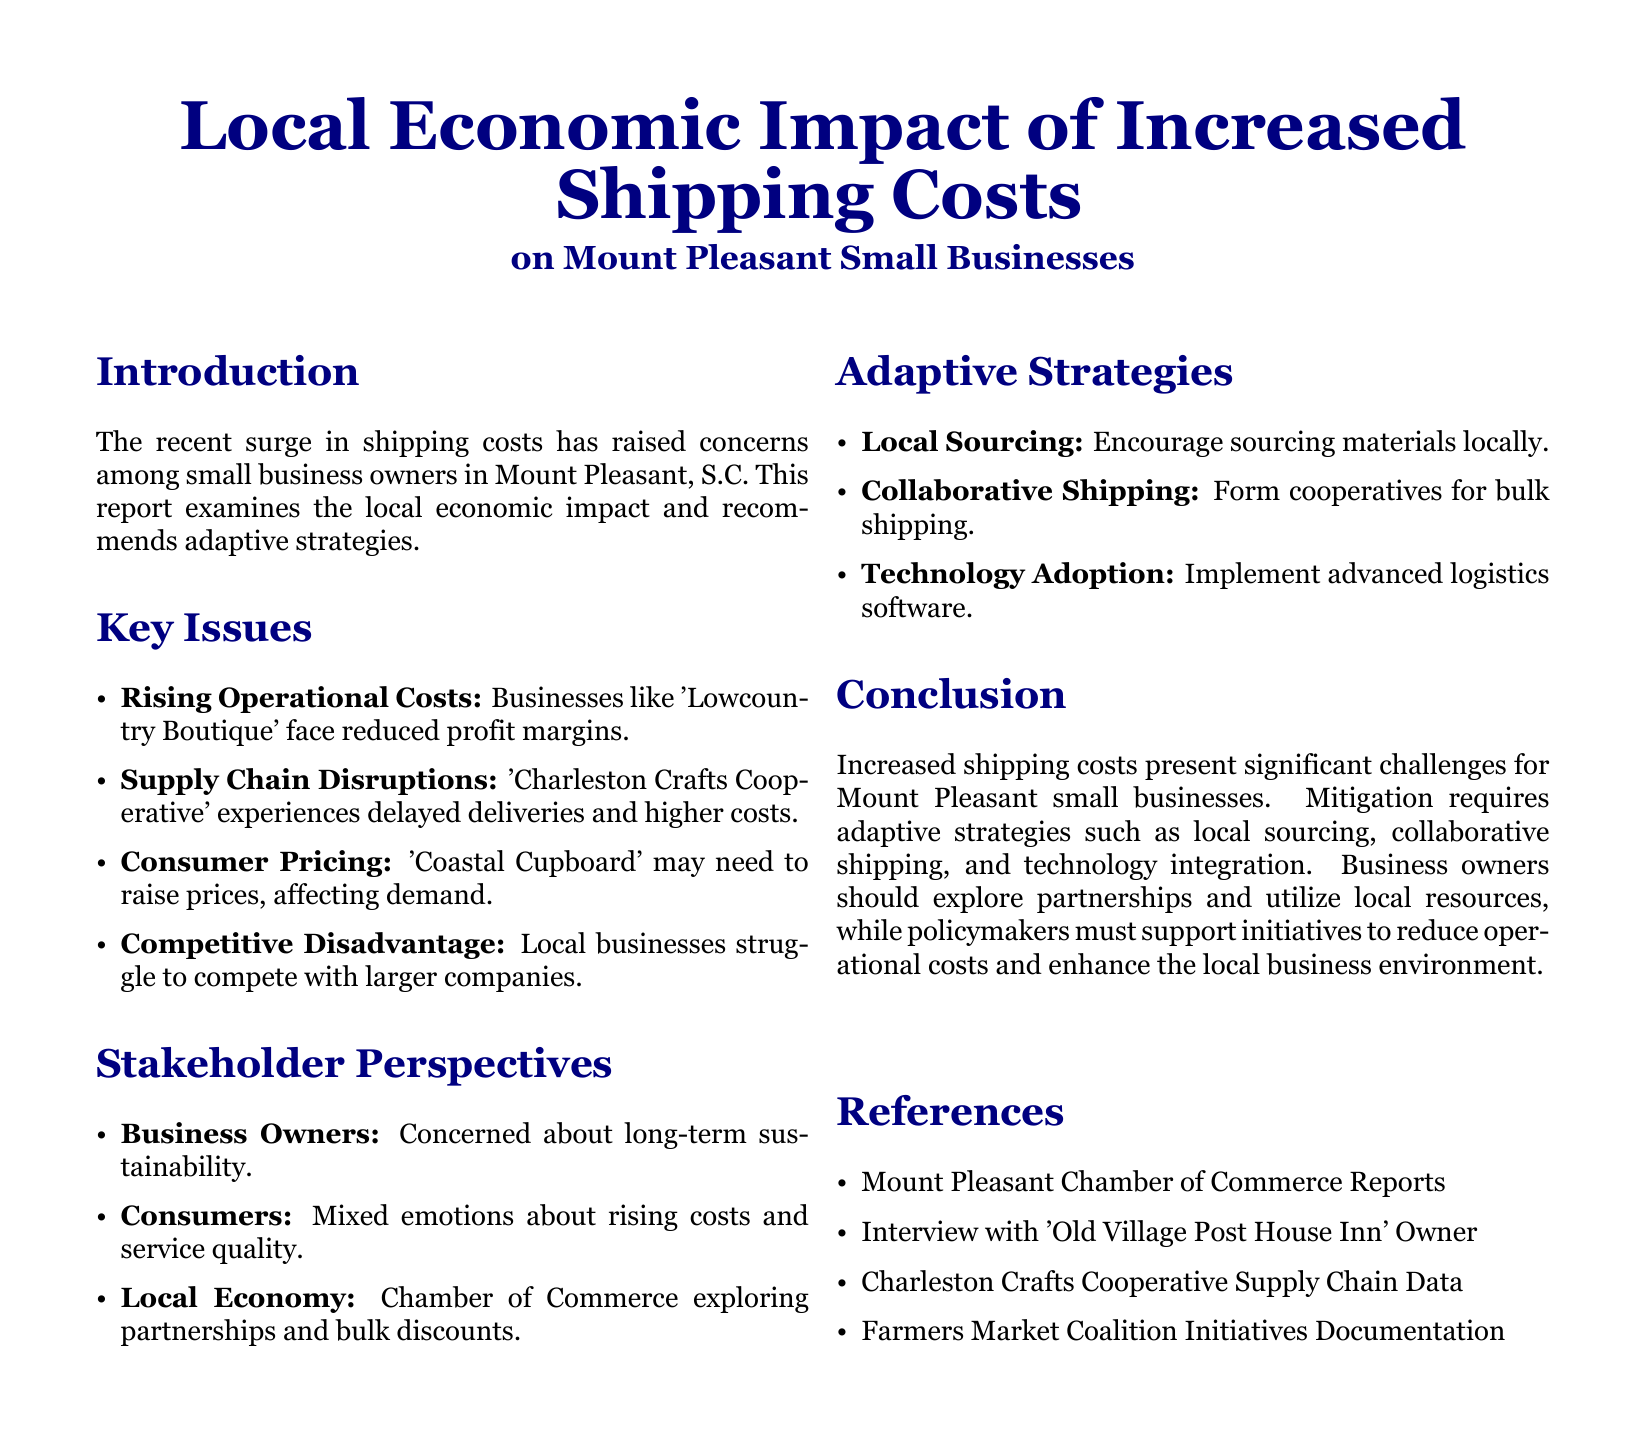What is the main focus of the report? The report primarily examines the local economic impact of increased shipping costs on small businesses in Mount Pleasant.
Answer: local economic impact of increased shipping costs Which business is mentioned as facing reduced profit margins? 'Lowcountry Boutique' is specifically identified as facing reduced profit margins due to rising operational costs.
Answer: Lowcountry Boutique What solution is suggested for improving shipping costs? The report recommends forming cooperatives for bulk shipping as a way to mitigate increased shipping costs.
Answer: collaborative shipping Which stakeholder group is concerned about long-term sustainability? Business Owners are noted as the stakeholder group concerned about the long-term sustainability of their enterprises.
Answer: Business Owners What does the Chamber of Commerce explore? The Chamber of Commerce is exploring partnerships and bulk discounts to address economic challenges.
Answer: partnerships and bulk discounts 